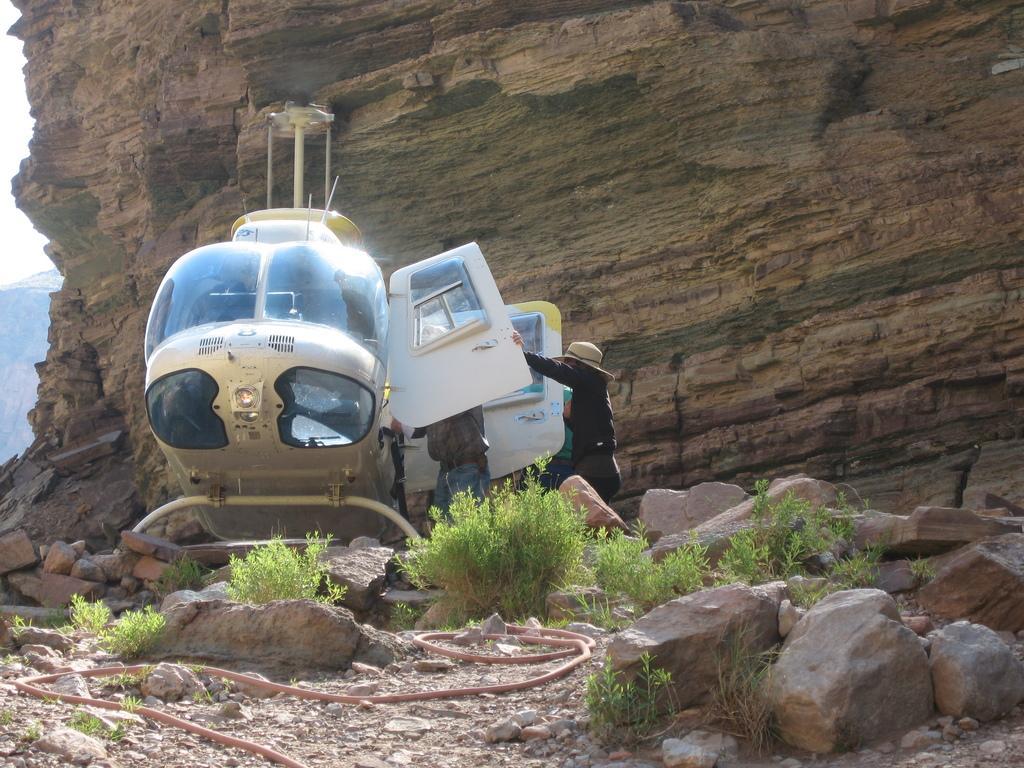In one or two sentences, can you explain what this image depicts? This picture is clicked outside. In the foreground we can see the plants and the stones and some objects lying on the ground. In the center we can see the two persons and a helicopter is parked on the ground. In the background we can see the sky and the rocks. 